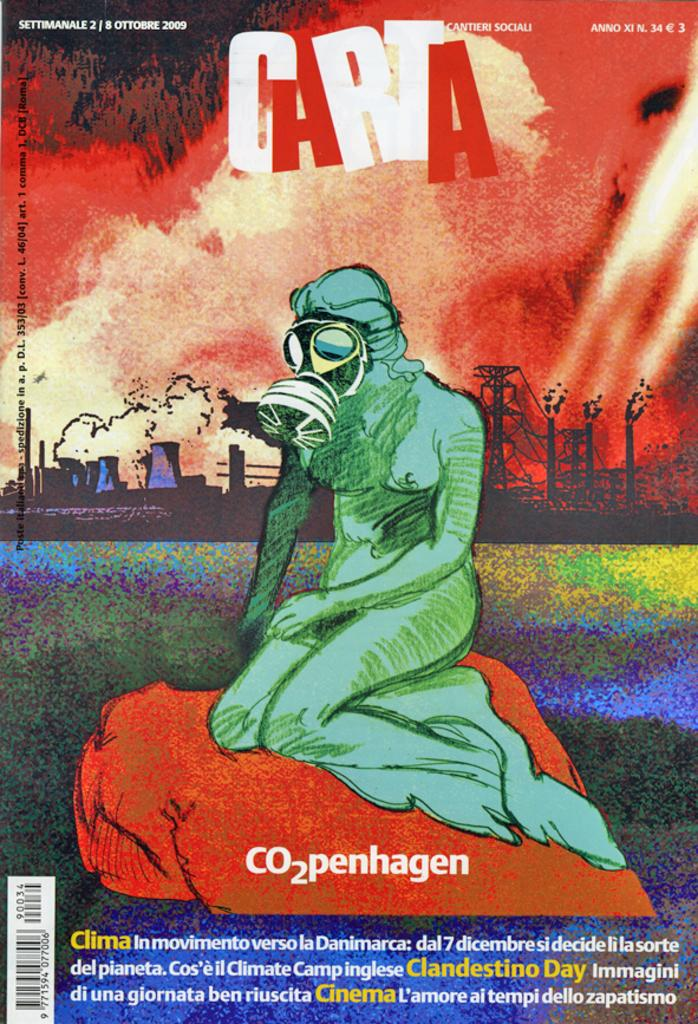<image>
Offer a succinct explanation of the picture presented. A promotional poster with a person wearing a gas mask for C02penhagen. 